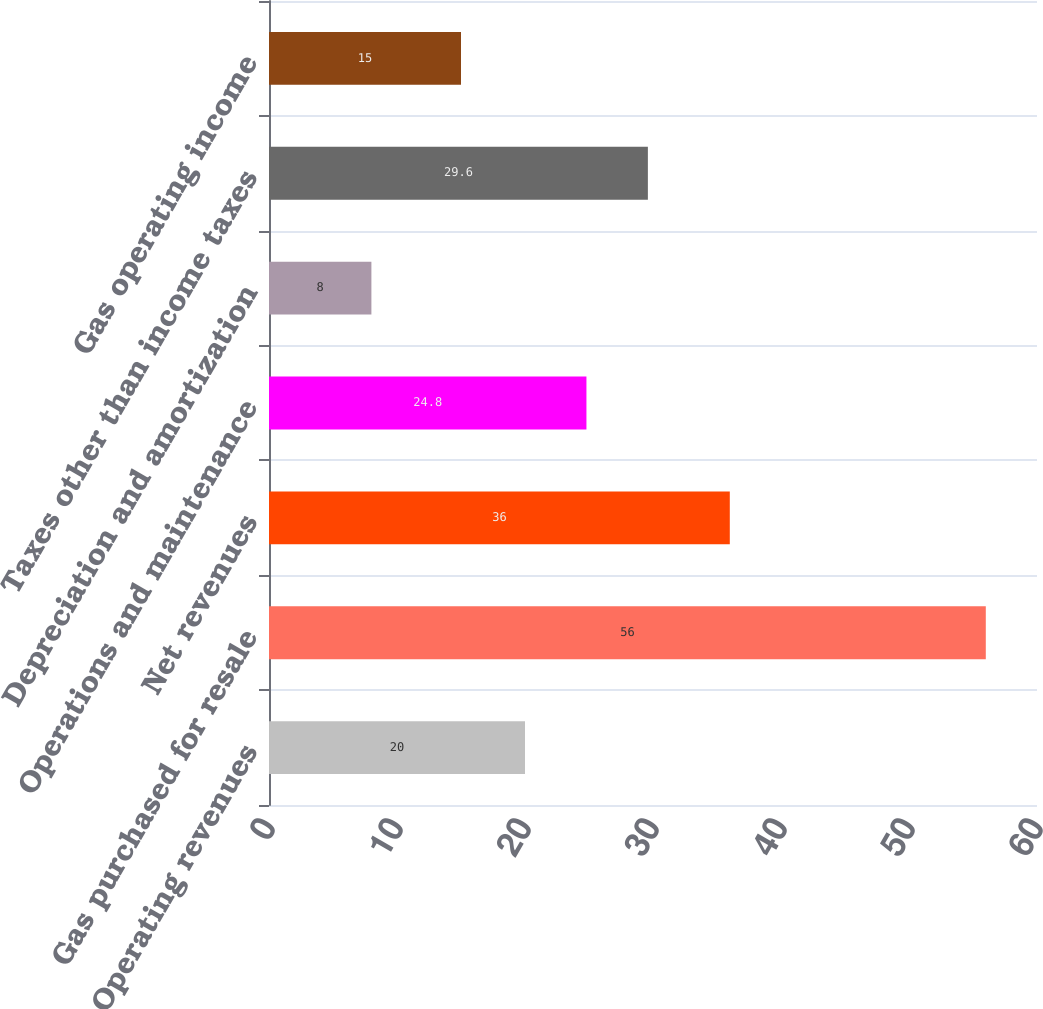Convert chart. <chart><loc_0><loc_0><loc_500><loc_500><bar_chart><fcel>Operating revenues<fcel>Gas purchased for resale<fcel>Net revenues<fcel>Operations and maintenance<fcel>Depreciation and amortization<fcel>Taxes other than income taxes<fcel>Gas operating income<nl><fcel>20<fcel>56<fcel>36<fcel>24.8<fcel>8<fcel>29.6<fcel>15<nl></chart> 